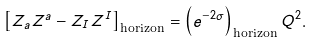<formula> <loc_0><loc_0><loc_500><loc_500>\left [ Z _ { a } Z ^ { a } - Z _ { I } Z ^ { I } \right ] _ { \text {horizon} } = \left ( e ^ { - 2 \sigma } \right ) _ { \text {horizon} } Q ^ { 2 } .</formula> 